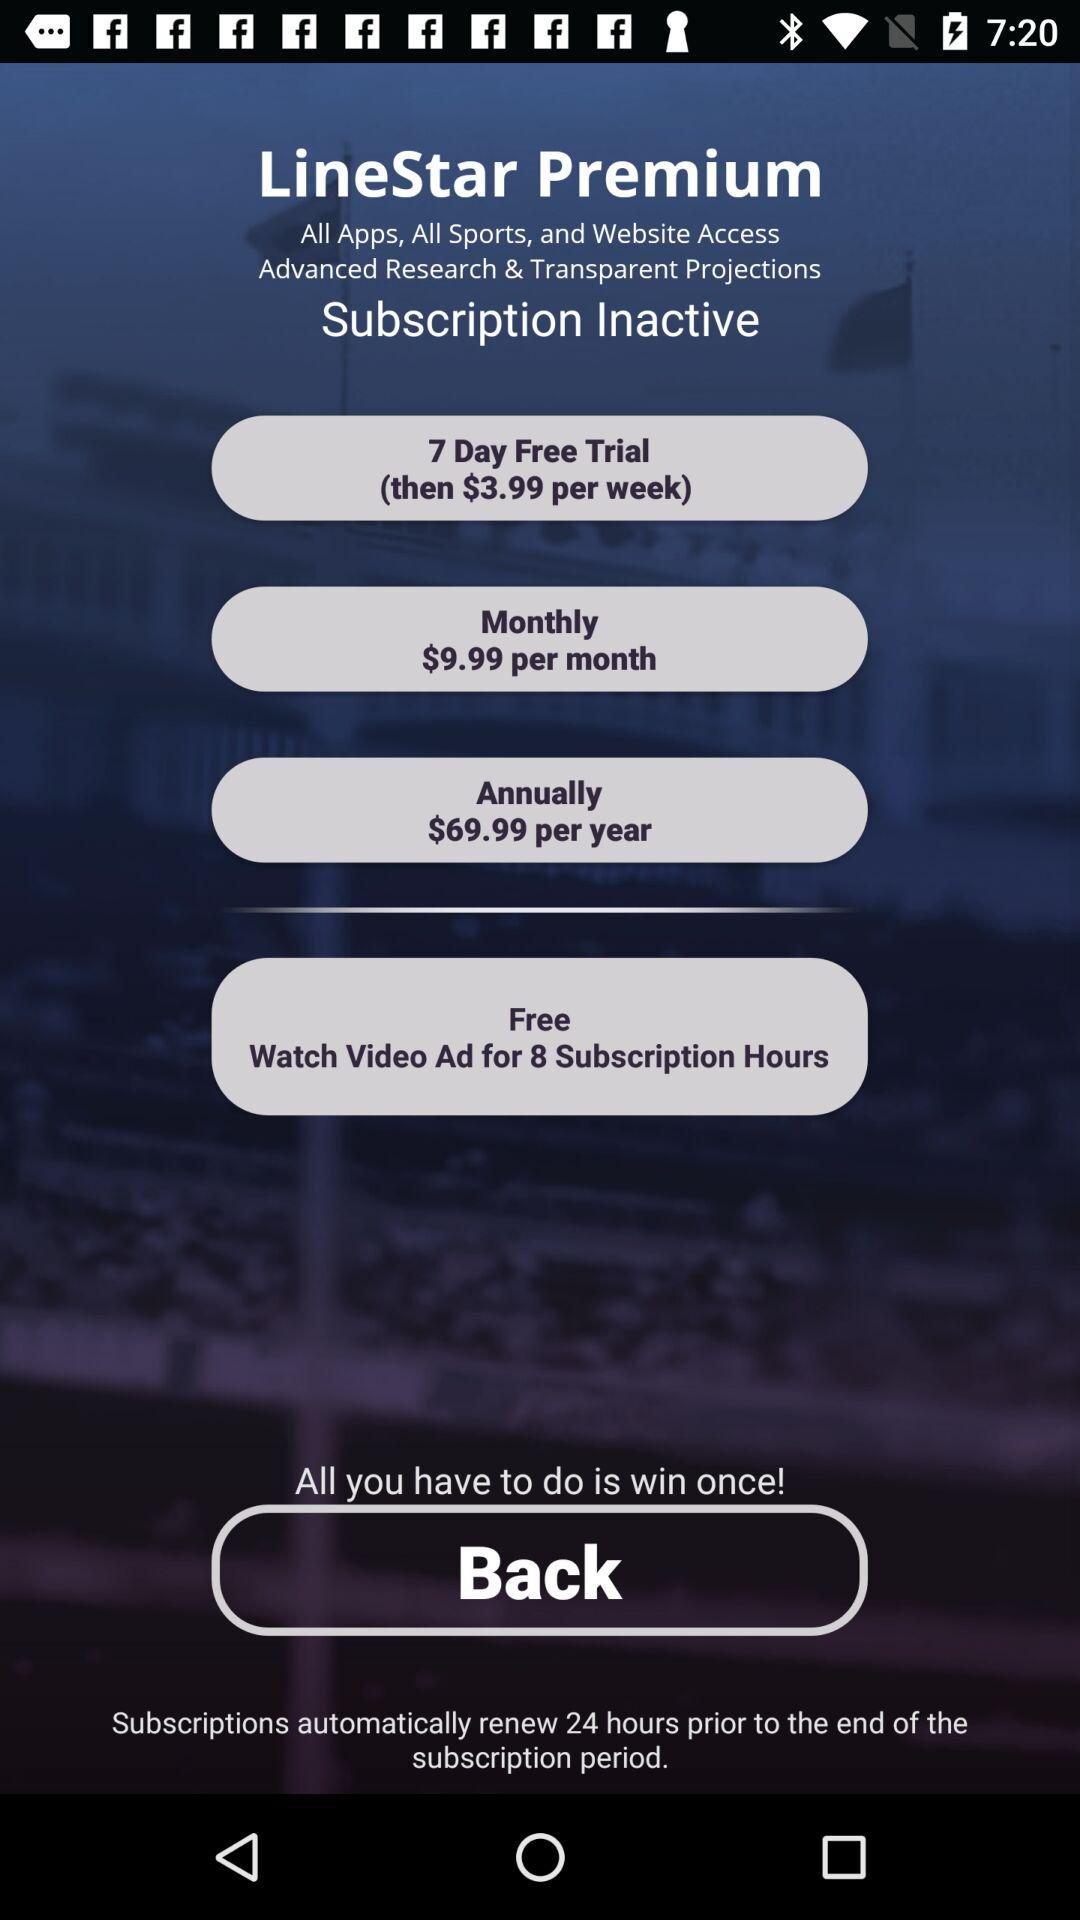How many subscription options are there?
Answer the question using a single word or phrase. 4 